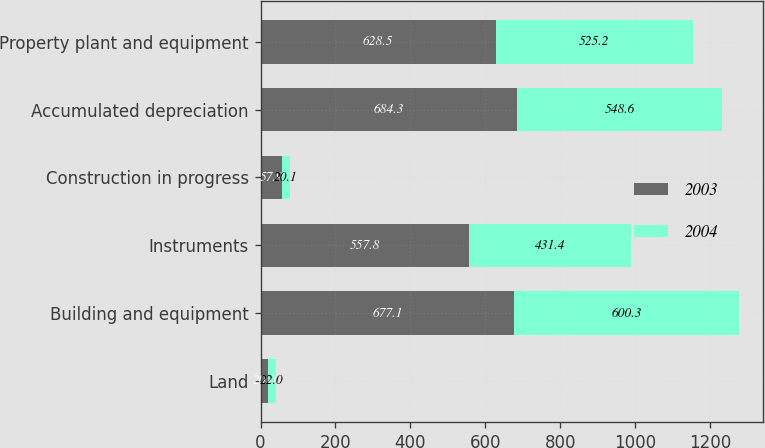Convert chart to OTSL. <chart><loc_0><loc_0><loc_500><loc_500><stacked_bar_chart><ecel><fcel>Land<fcel>Building and equipment<fcel>Instruments<fcel>Construction in progress<fcel>Accumulated depreciation<fcel>Property plant and equipment<nl><fcel>2003<fcel>20<fcel>677.1<fcel>557.8<fcel>57.9<fcel>684.3<fcel>628.5<nl><fcel>2004<fcel>22<fcel>600.3<fcel>431.4<fcel>20.1<fcel>548.6<fcel>525.2<nl></chart> 